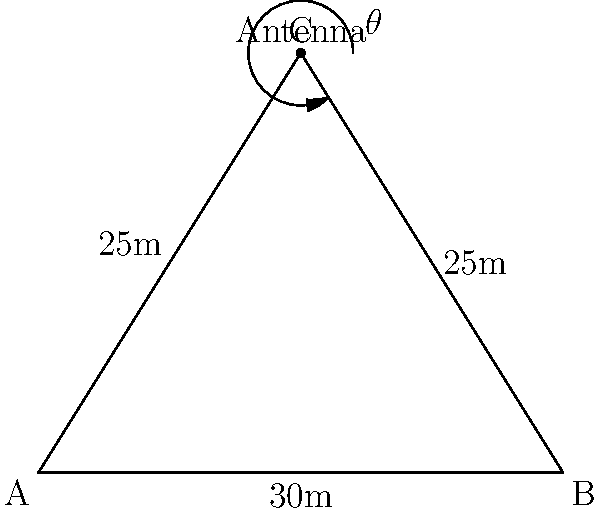In a data center, a wireless network antenna needs to be placed at point C to cover two server racks located at points A and B. The distance between the racks (AB) is 30m, and the antenna is placed 25m from each rack. What is the optimal angle $\theta$ (in degrees) at which the antenna should be positioned to provide equal coverage to both racks? To solve this problem, we'll use the law of cosines and basic trigonometry:

1) First, we recognize that triangle ABC is isosceles, as AC = BC = 25m.

2) We can use the law of cosines to find angle ACB:
   $\cos(ACB) = \frac{AC^2 + BC^2 - AB^2}{2(AC)(BC)}$
   
   $\cos(ACB) = \frac{25^2 + 25^2 - 30^2}{2(25)(25)} = \frac{1250 - 900}{1250} = \frac{350}{1250} = 0.28$

3) $ACB = \arccos(0.28) \approx 73.74°$

4) Since triangle ABC is isosceles, angles CAB and CBA are equal.
   Let's call this angle $x$. We know that in a triangle, all angles sum to 180°:
   
   $2x + 73.74° = 180°$
   $2x = 106.26°$
   $x = 53.13°$

5) The optimal angle $\theta$ is the supplement of $x$:
   $\theta = 180° - 53.13° = 126.87°$

6) Rounding to the nearest degree: $\theta \approx 127°$

This angle ensures that the antenna's signal strength is balanced between both server racks.
Answer: 127° 